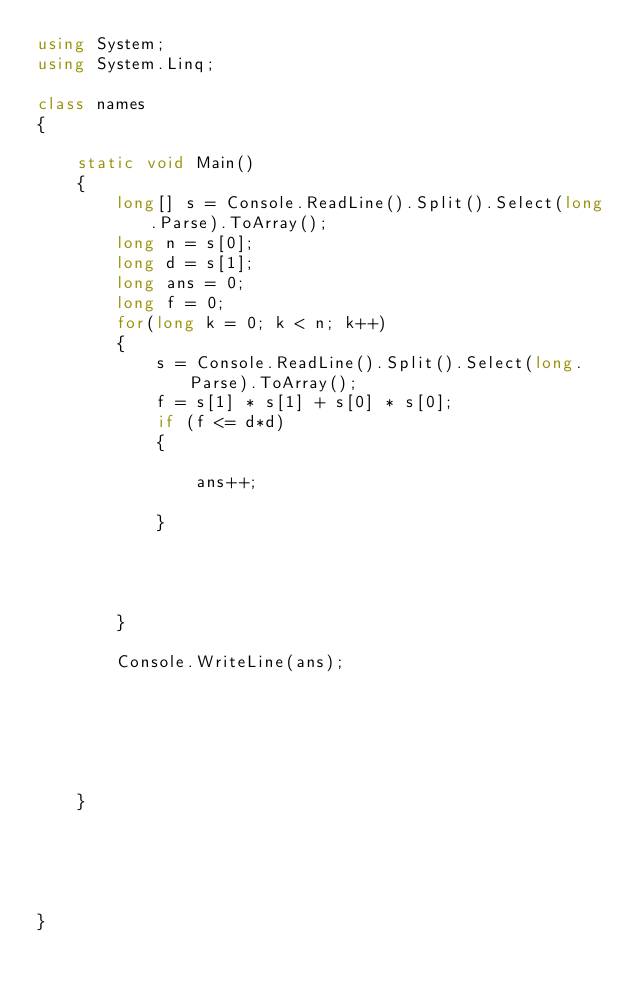<code> <loc_0><loc_0><loc_500><loc_500><_C#_>using System;
using System.Linq;

class names
{

    static void Main()
    {
        long[] s = Console.ReadLine().Split().Select(long.Parse).ToArray();
        long n = s[0];
        long d = s[1];
        long ans = 0;
        long f = 0;
        for(long k = 0; k < n; k++)
        {
            s = Console.ReadLine().Split().Select(long.Parse).ToArray();
            f = s[1] * s[1] + s[0] * s[0];
            if (f <= d*d)
            {

                ans++;

            }




        }

        Console.WriteLine(ans);






    }





}</code> 